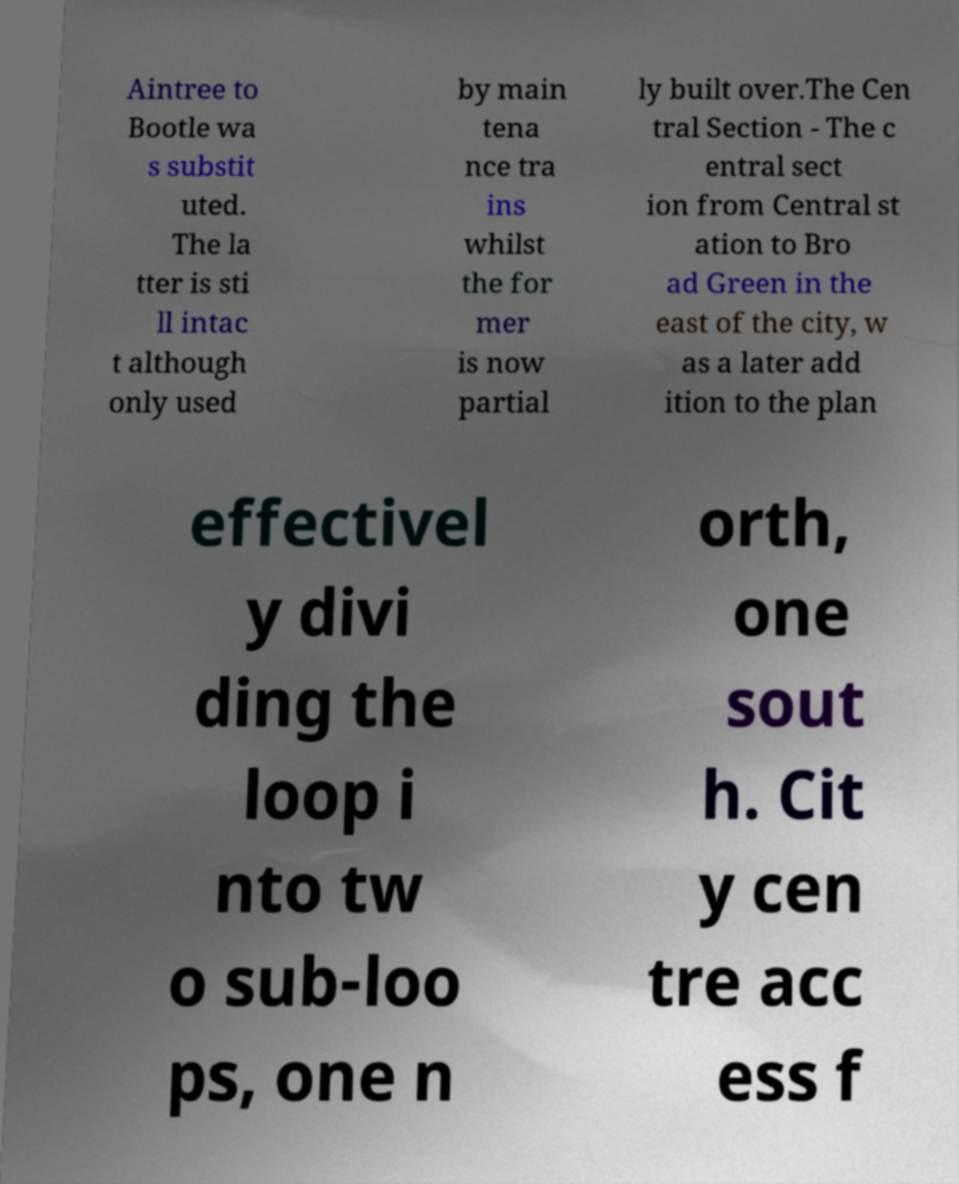I need the written content from this picture converted into text. Can you do that? Aintree to Bootle wa s substit uted. The la tter is sti ll intac t although only used by main tena nce tra ins whilst the for mer is now partial ly built over.The Cen tral Section - The c entral sect ion from Central st ation to Bro ad Green in the east of the city, w as a later add ition to the plan effectivel y divi ding the loop i nto tw o sub-loo ps, one n orth, one sout h. Cit y cen tre acc ess f 